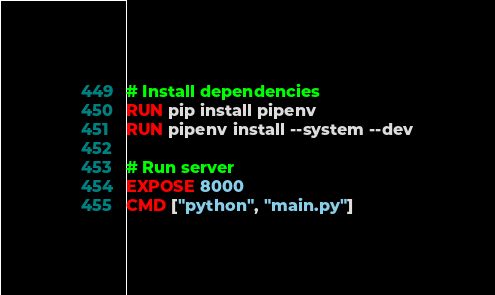Convert code to text. <code><loc_0><loc_0><loc_500><loc_500><_Dockerfile_>
# Install dependencies
RUN pip install pipenv
RUN pipenv install --system --dev

# Run server
EXPOSE 8000
CMD ["python", "main.py"]
</code> 